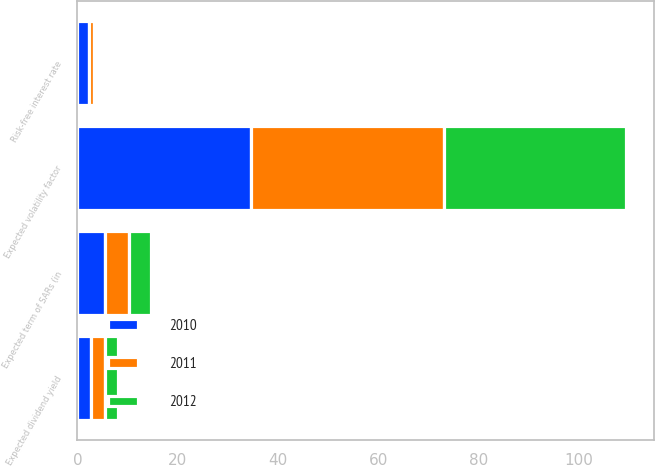Convert chart. <chart><loc_0><loc_0><loc_500><loc_500><stacked_bar_chart><ecel><fcel>Expected term of SARs (in<fcel>Expected volatility factor<fcel>Expected dividend yield<fcel>Risk-free interest rate<nl><fcel>2012<fcel>4.49<fcel>36.44<fcel>2.69<fcel>0.72<nl><fcel>2011<fcel>4.67<fcel>38.45<fcel>2.72<fcel>0.83<nl><fcel>2010<fcel>5.54<fcel>34.59<fcel>2.76<fcel>2.39<nl></chart> 